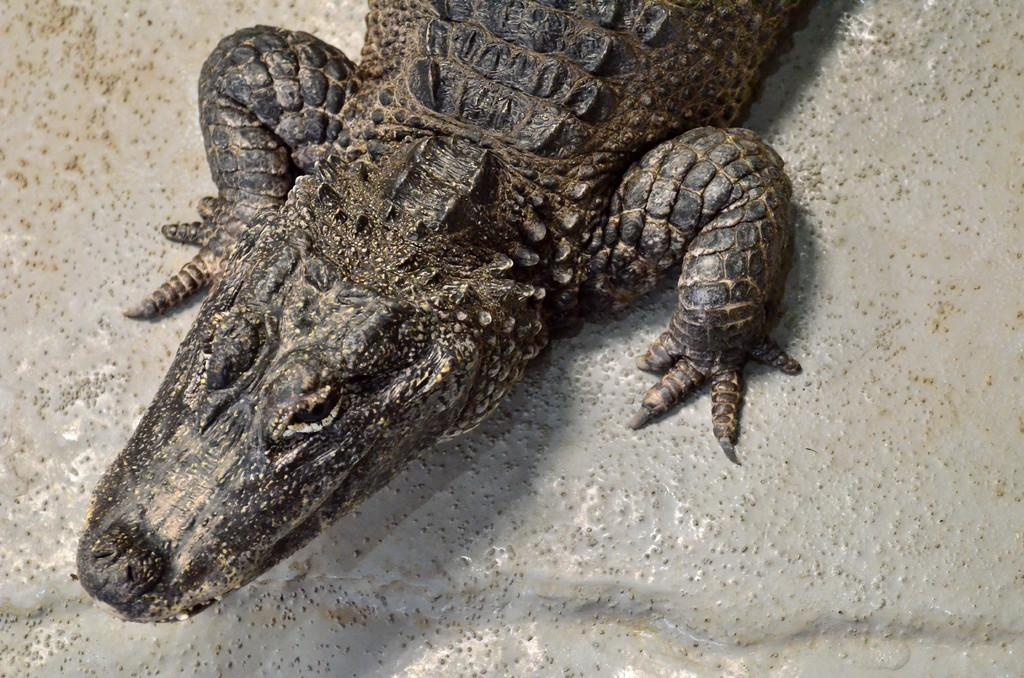What type of animal is in the image? There is a crocodile or a reptile in the image. What color is the crocodile or reptile? The crocodile or reptile is black in color. What can be seen in the background of the image? There is a white wall in the background of the image. How many fangs does the vegetable have in the image? There is no vegetable present in the image, and therefore no fangs can be observed. 